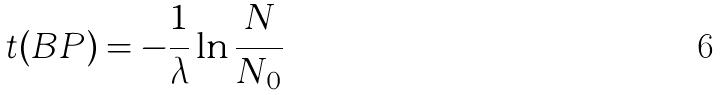Convert formula to latex. <formula><loc_0><loc_0><loc_500><loc_500>t ( B P ) = - \frac { 1 } { \lambda } \ln \frac { N } { N _ { 0 } }</formula> 